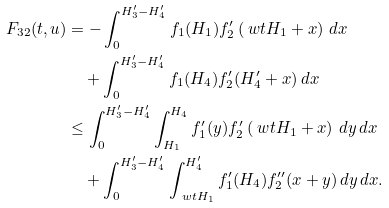Convert formula to latex. <formula><loc_0><loc_0><loc_500><loc_500>F _ { 3 2 } ( t , u ) & = - \int _ { 0 } ^ { H _ { 3 } ^ { \prime } - H _ { 4 } ^ { \prime } } f _ { 1 } ( H _ { 1 } ) f _ { 2 } ^ { \prime } \left ( \ w t H _ { 1 } + x \right ) \, d x \\ & \quad + \int _ { 0 } ^ { H _ { 3 } ^ { \prime } - H _ { 4 } ^ { \prime } } f _ { 1 } ( H _ { 4 } ) f _ { 2 } ^ { \prime } ( H _ { 4 } ^ { \prime } + x ) \, d x \\ & \leq \int _ { 0 } ^ { H _ { 3 } ^ { \prime } - H _ { 4 } ^ { \prime } } \int _ { H _ { 1 } } ^ { H _ { 4 } } f _ { 1 } ^ { \prime } ( y ) f _ { 2 } ^ { \prime } \left ( \ w t H _ { 1 } + x \right ) \, d y \, d x \\ & \quad + \int _ { 0 } ^ { H _ { 3 } ^ { \prime } - H _ { 4 } ^ { \prime } } \int _ { \ w t H _ { 1 } } ^ { H _ { 4 } ^ { \prime } } f _ { 1 } ^ { \prime } ( H _ { 4 } ) f _ { 2 } ^ { \prime \prime } ( x + y ) \, d y \, d x .</formula> 